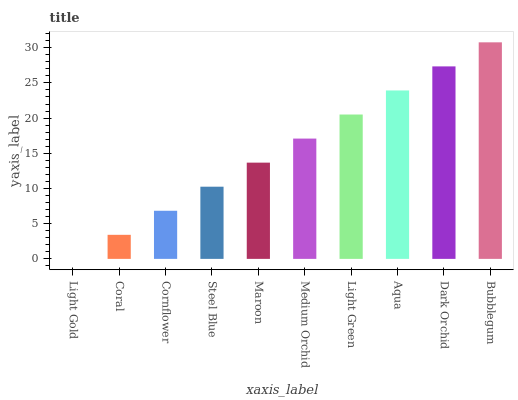Is Light Gold the minimum?
Answer yes or no. Yes. Is Bubblegum the maximum?
Answer yes or no. Yes. Is Coral the minimum?
Answer yes or no. No. Is Coral the maximum?
Answer yes or no. No. Is Coral greater than Light Gold?
Answer yes or no. Yes. Is Light Gold less than Coral?
Answer yes or no. Yes. Is Light Gold greater than Coral?
Answer yes or no. No. Is Coral less than Light Gold?
Answer yes or no. No. Is Medium Orchid the high median?
Answer yes or no. Yes. Is Maroon the low median?
Answer yes or no. Yes. Is Aqua the high median?
Answer yes or no. No. Is Steel Blue the low median?
Answer yes or no. No. 